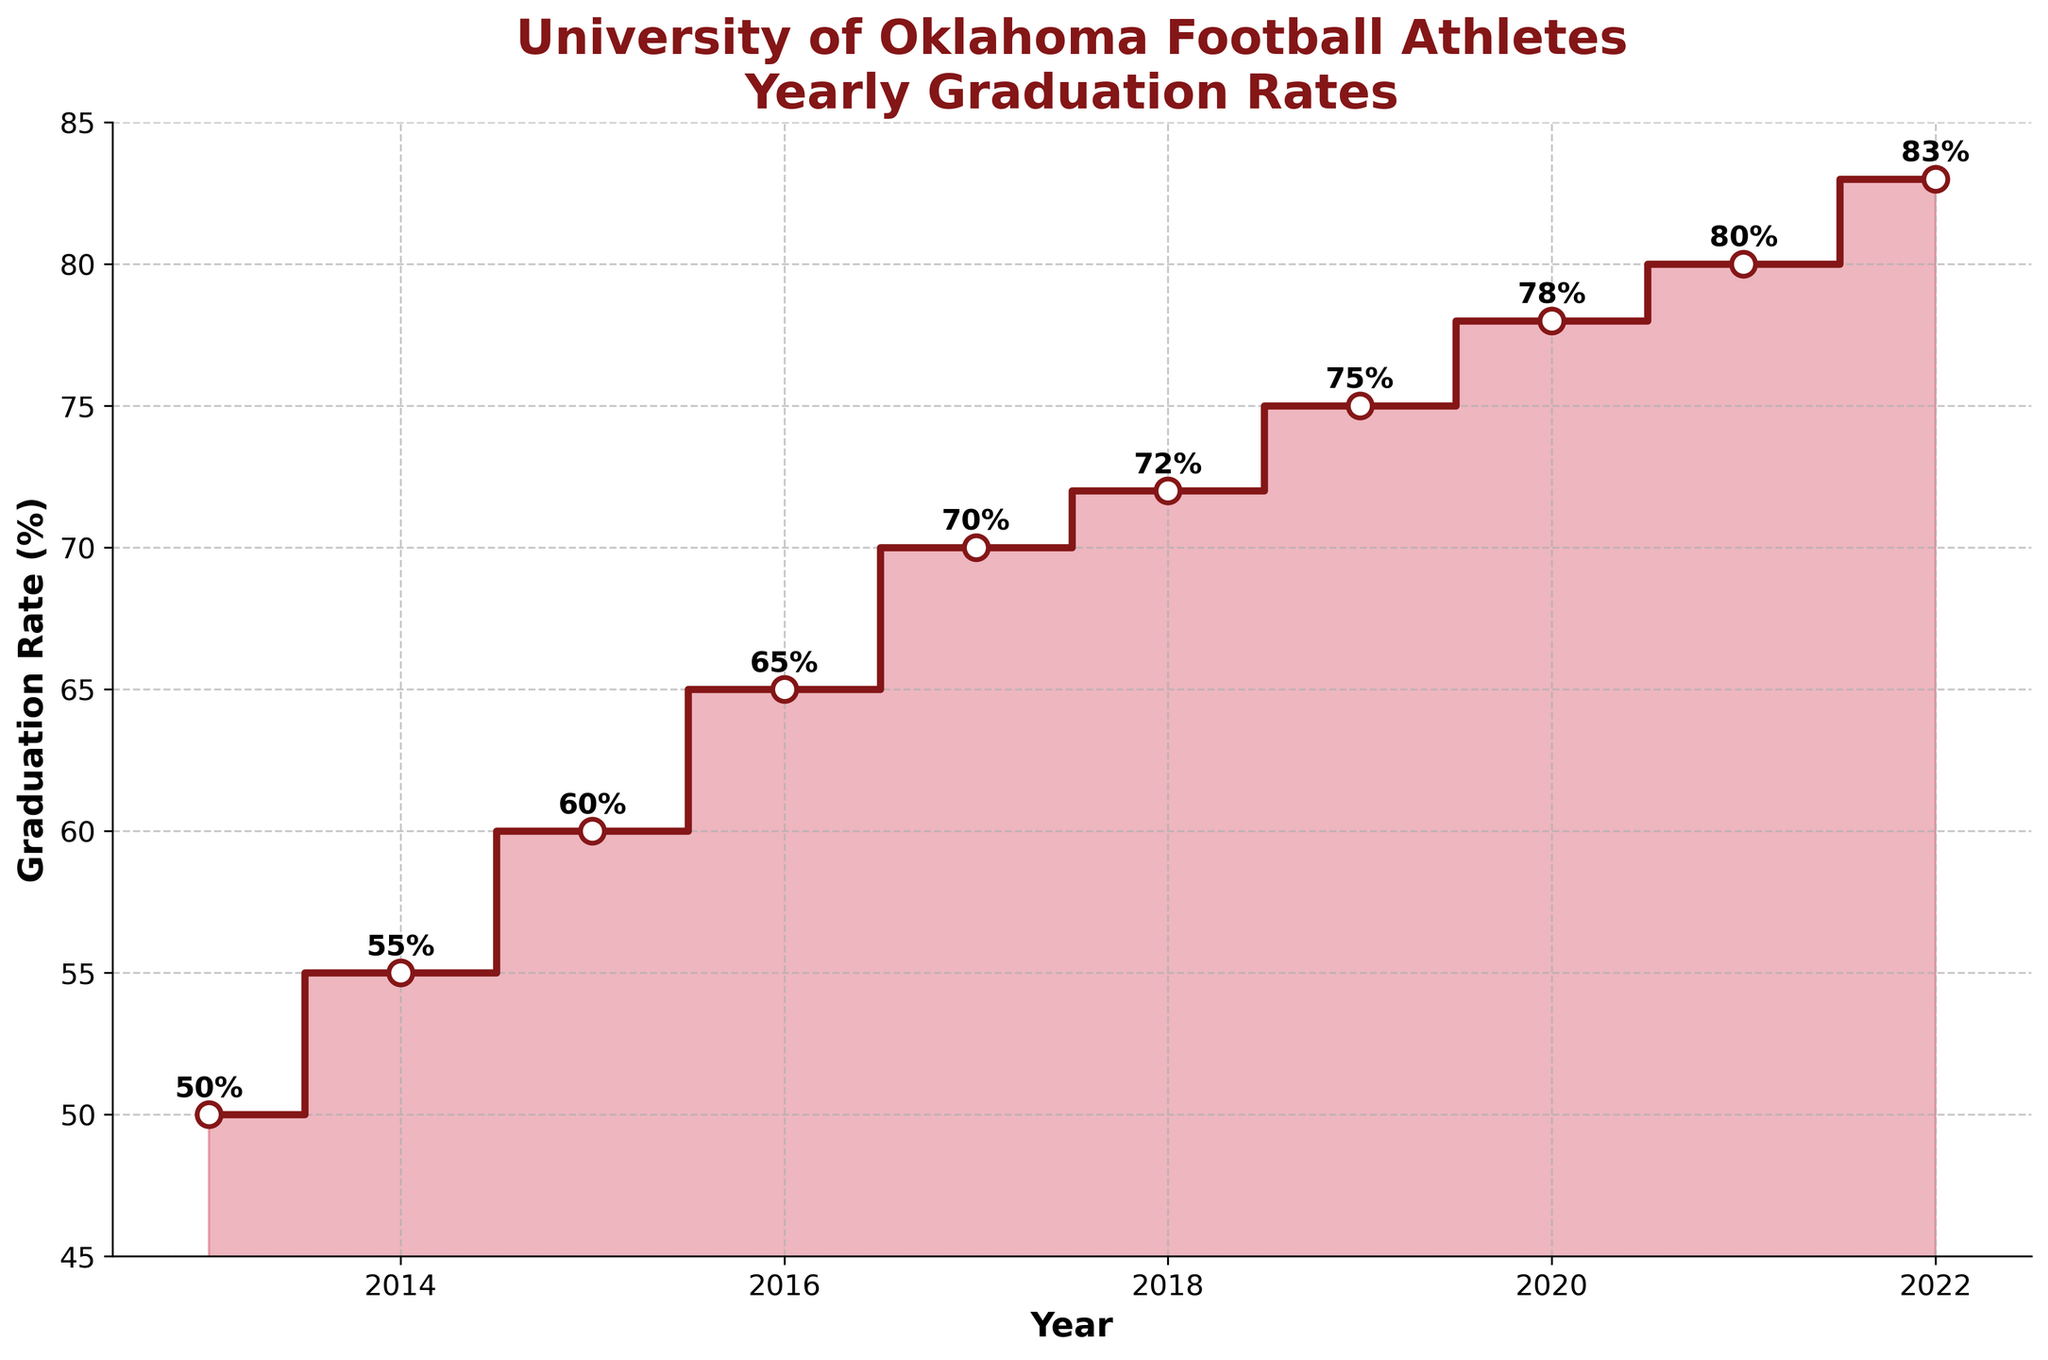How many years of data are presented in the figure? The x-axis shows the year from 2013 to 2022. Counting these, there are 10 years of data.
Answer: 10 What is the graduation rate for the year 2020? Locate the data point on the plot for the year 2020, which is marked at 78%.
Answer: 78% Between which two consecutive years did the graduation rate increase the most? Compare the step height between consecutive years; the largest gap is between 2015 and 2016, where it increased from 60% to 65%.
Answer: 2015 and 2016 What is the average graduation rate over the years presented? Sum the graduation rates and divide by the number of years: (50+55+60+65+70+72+75+78+80+83) / 10 = 688 / 10 = 68.8%.
Answer: 68.8% Has the graduation rate ever decreased or remained constant from year to year? Check the steps on the plot for any horizontal or downward steps; all steps are upward, indicating a continual increase.
Answer: No In which year did the graduation rate first exceed 70%? Check the plot, the graduation rate first exceeds 70% in 2017.
Answer: 2017 What is the range of the graduation rates presented in the figure? Subtract the minimum rate (50% in 2013) from the maximum rate (83% in 2022): 83% - 50% = 33%.
Answer: 33% By how much did the graduation rate improve from 2013 to 2022? Subtract the graduation rate of 2013 from the rate of 2022: 83% - 50% = 33%.
Answer: 33% Which two years have the closest graduation rates? Compare the differences between consecutive years; the smallest difference is between 2017 (70%) and 2018 (72%), with a difference of 2%.
Answer: 2017 and 2018 What is the title of the figure? Read the title at the top of the plot: "University of Oklahoma Football Athletes Yearly Graduation Rates”.
Answer: "University of Oklahoma Football Athletes Yearly Graduation Rates" 